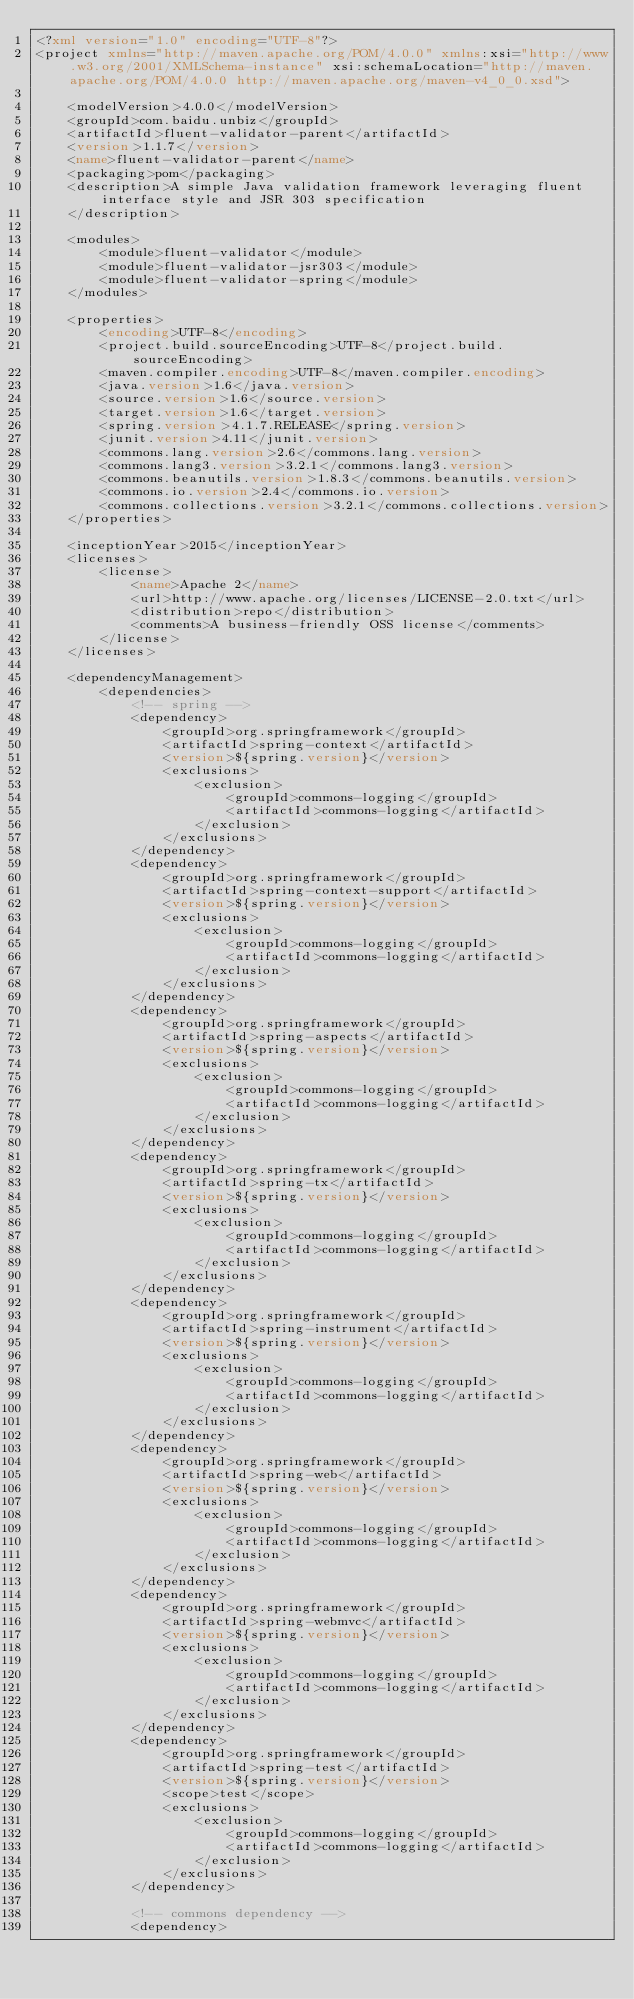<code> <loc_0><loc_0><loc_500><loc_500><_XML_><?xml version="1.0" encoding="UTF-8"?>
<project xmlns="http://maven.apache.org/POM/4.0.0" xmlns:xsi="http://www.w3.org/2001/XMLSchema-instance" xsi:schemaLocation="http://maven.apache.org/POM/4.0.0 http://maven.apache.org/maven-v4_0_0.xsd">

    <modelVersion>4.0.0</modelVersion>
    <groupId>com.baidu.unbiz</groupId>
    <artifactId>fluent-validator-parent</artifactId>
    <version>1.1.7</version>
    <name>fluent-validator-parent</name>
    <packaging>pom</packaging>
    <description>A simple Java validation framework leveraging fluent interface style and JSR 303 specification
    </description>

    <modules>
        <module>fluent-validator</module>
        <module>fluent-validator-jsr303</module>
        <module>fluent-validator-spring</module>
    </modules>

    <properties>
        <encoding>UTF-8</encoding>
        <project.build.sourceEncoding>UTF-8</project.build.sourceEncoding>
        <maven.compiler.encoding>UTF-8</maven.compiler.encoding>
        <java.version>1.6</java.version>
        <source.version>1.6</source.version>
        <target.version>1.6</target.version>
        <spring.version>4.1.7.RELEASE</spring.version>
        <junit.version>4.11</junit.version>
        <commons.lang.version>2.6</commons.lang.version>
        <commons.lang3.version>3.2.1</commons.lang3.version>
        <commons.beanutils.version>1.8.3</commons.beanutils.version>
        <commons.io.version>2.4</commons.io.version>
        <commons.collections.version>3.2.1</commons.collections.version>
    </properties>

    <inceptionYear>2015</inceptionYear>
    <licenses>
        <license>
            <name>Apache 2</name>
            <url>http://www.apache.org/licenses/LICENSE-2.0.txt</url>
            <distribution>repo</distribution>
            <comments>A business-friendly OSS license</comments>
        </license>
    </licenses>

    <dependencyManagement>
        <dependencies>
            <!-- spring -->
            <dependency>
                <groupId>org.springframework</groupId>
                <artifactId>spring-context</artifactId>
                <version>${spring.version}</version>
                <exclusions>
                    <exclusion>
                        <groupId>commons-logging</groupId>
                        <artifactId>commons-logging</artifactId>
                    </exclusion>
                </exclusions>
            </dependency>
            <dependency>
                <groupId>org.springframework</groupId>
                <artifactId>spring-context-support</artifactId>
                <version>${spring.version}</version>
                <exclusions>
                    <exclusion>
                        <groupId>commons-logging</groupId>
                        <artifactId>commons-logging</artifactId>
                    </exclusion>
                </exclusions>
            </dependency>
            <dependency>
                <groupId>org.springframework</groupId>
                <artifactId>spring-aspects</artifactId>
                <version>${spring.version}</version>
                <exclusions>
                    <exclusion>
                        <groupId>commons-logging</groupId>
                        <artifactId>commons-logging</artifactId>
                    </exclusion>
                </exclusions>
            </dependency>
            <dependency>
                <groupId>org.springframework</groupId>
                <artifactId>spring-tx</artifactId>
                <version>${spring.version}</version>
                <exclusions>
                    <exclusion>
                        <groupId>commons-logging</groupId>
                        <artifactId>commons-logging</artifactId>
                    </exclusion>
                </exclusions>
            </dependency>
            <dependency>
                <groupId>org.springframework</groupId>
                <artifactId>spring-instrument</artifactId>
                <version>${spring.version}</version>
                <exclusions>
                    <exclusion>
                        <groupId>commons-logging</groupId>
                        <artifactId>commons-logging</artifactId>
                    </exclusion>
                </exclusions>
            </dependency>
            <dependency>
                <groupId>org.springframework</groupId>
                <artifactId>spring-web</artifactId>
                <version>${spring.version}</version>
                <exclusions>
                    <exclusion>
                        <groupId>commons-logging</groupId>
                        <artifactId>commons-logging</artifactId>
                    </exclusion>
                </exclusions>
            </dependency>
            <dependency>
                <groupId>org.springframework</groupId>
                <artifactId>spring-webmvc</artifactId>
                <version>${spring.version}</version>
                <exclusions>
                    <exclusion>
                        <groupId>commons-logging</groupId>
                        <artifactId>commons-logging</artifactId>
                    </exclusion>
                </exclusions>
            </dependency>
            <dependency>
                <groupId>org.springframework</groupId>
                <artifactId>spring-test</artifactId>
                <version>${spring.version}</version>
                <scope>test</scope>
                <exclusions>
                    <exclusion>
                        <groupId>commons-logging</groupId>
                        <artifactId>commons-logging</artifactId>
                    </exclusion>
                </exclusions>
            </dependency>

            <!-- commons dependency -->
            <dependency></code> 